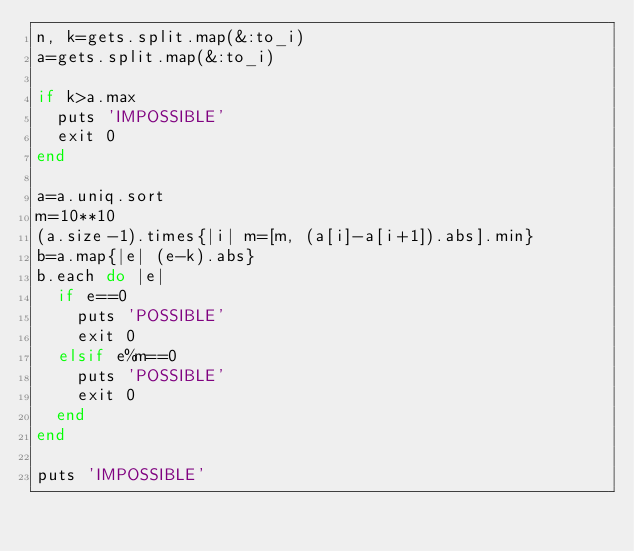<code> <loc_0><loc_0><loc_500><loc_500><_Ruby_>n, k=gets.split.map(&:to_i)
a=gets.split.map(&:to_i)

if k>a.max
  puts 'IMPOSSIBLE'
  exit 0
end

a=a.uniq.sort
m=10**10
(a.size-1).times{|i| m=[m, (a[i]-a[i+1]).abs].min}
b=a.map{|e| (e-k).abs}
b.each do |e|
  if e==0
    puts 'POSSIBLE'
    exit 0
  elsif e%m==0
    puts 'POSSIBLE'
    exit 0
  end
end

puts 'IMPOSSIBLE'
</code> 